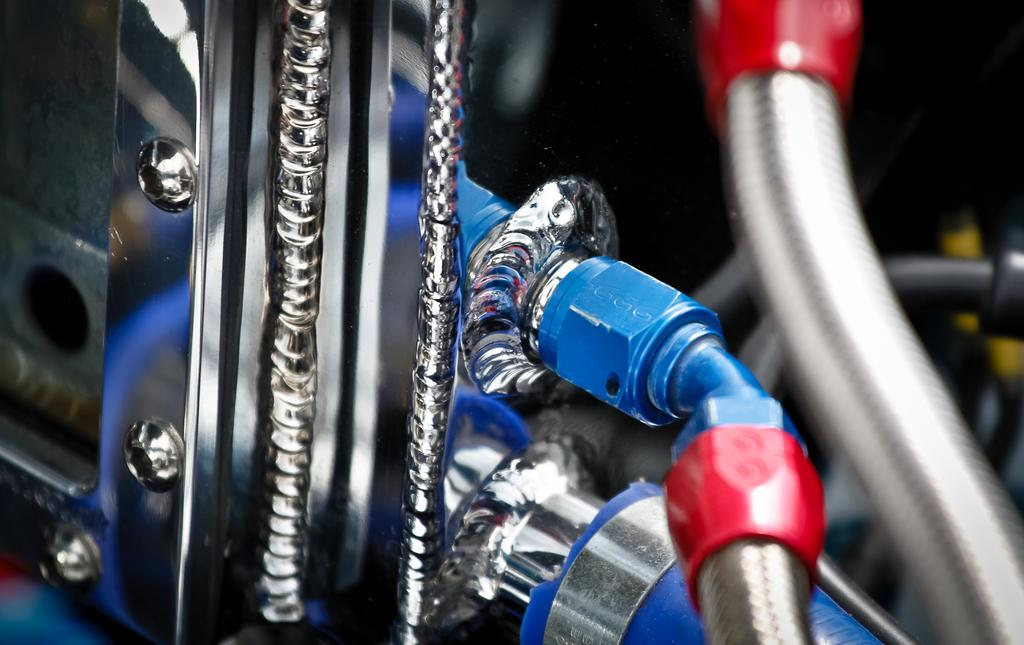What type of objects can be seen in the image? There are metal objects in the image. Can you identify any specific components of the metal objects? Yes, there are screws in the image. What is the color of the background in the image? The background of the image is dark. How many cherries are visible on the metal objects in the image? There are no cherries present in the image; it features metal objects and screws. What type of pollution can be seen in the image? There is no pollution visible in the image; it only contains metal objects and screws. 